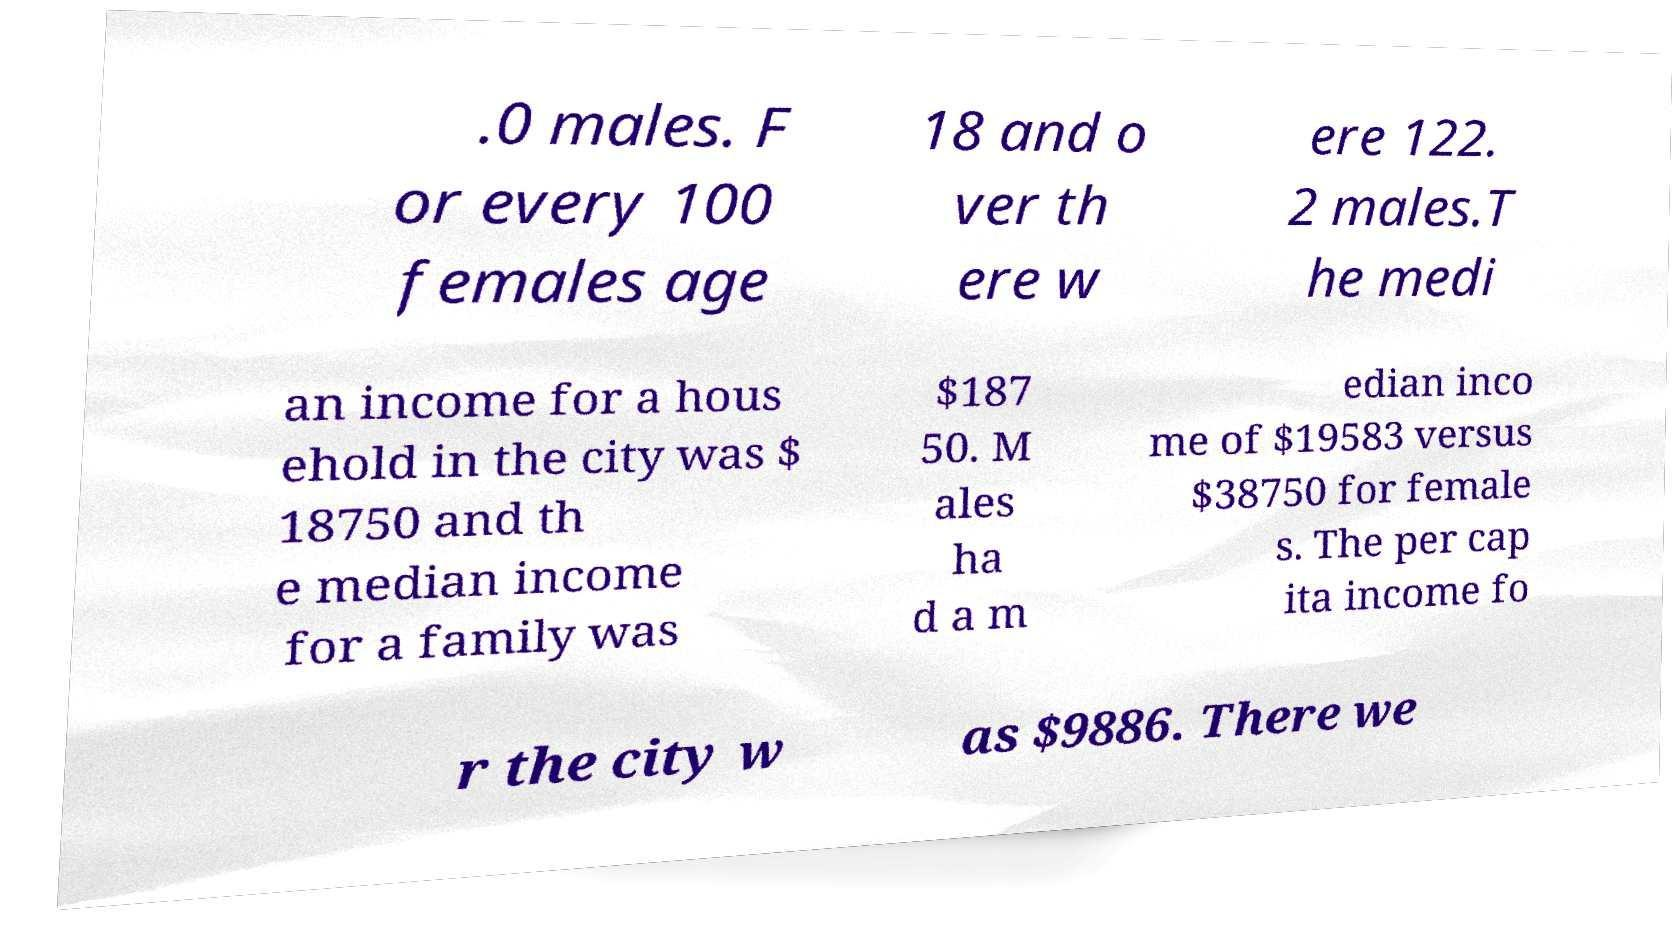Can you accurately transcribe the text from the provided image for me? .0 males. F or every 100 females age 18 and o ver th ere w ere 122. 2 males.T he medi an income for a hous ehold in the city was $ 18750 and th e median income for a family was $187 50. M ales ha d a m edian inco me of $19583 versus $38750 for female s. The per cap ita income fo r the city w as $9886. There we 